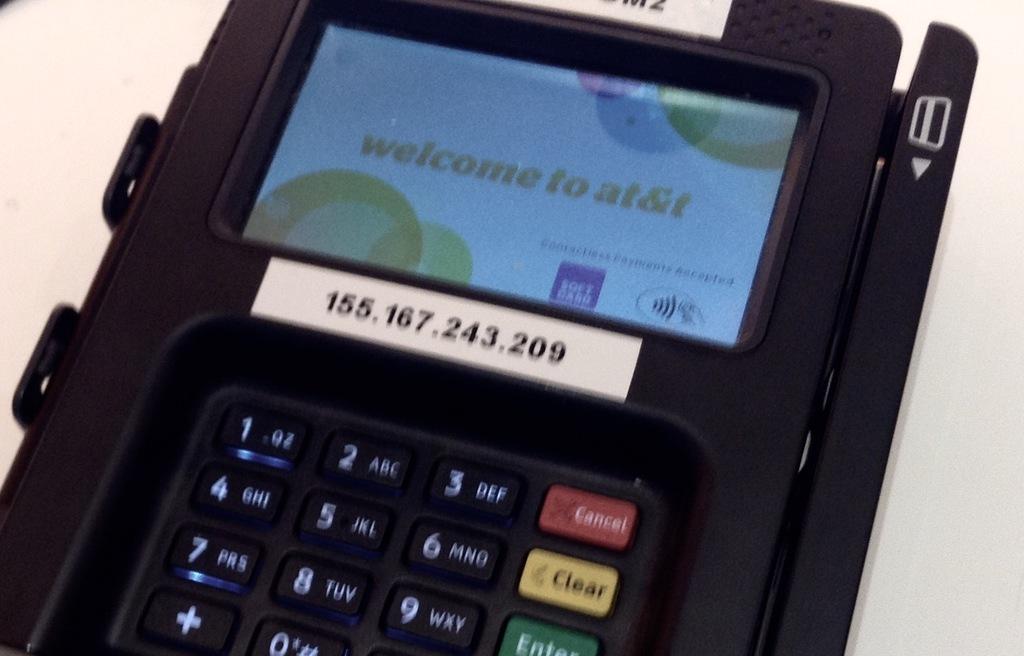What are the numbers on the sticker?
Offer a very short reply. 155.167.243.209. Is this an att credit card machine?
Your response must be concise. Yes. 